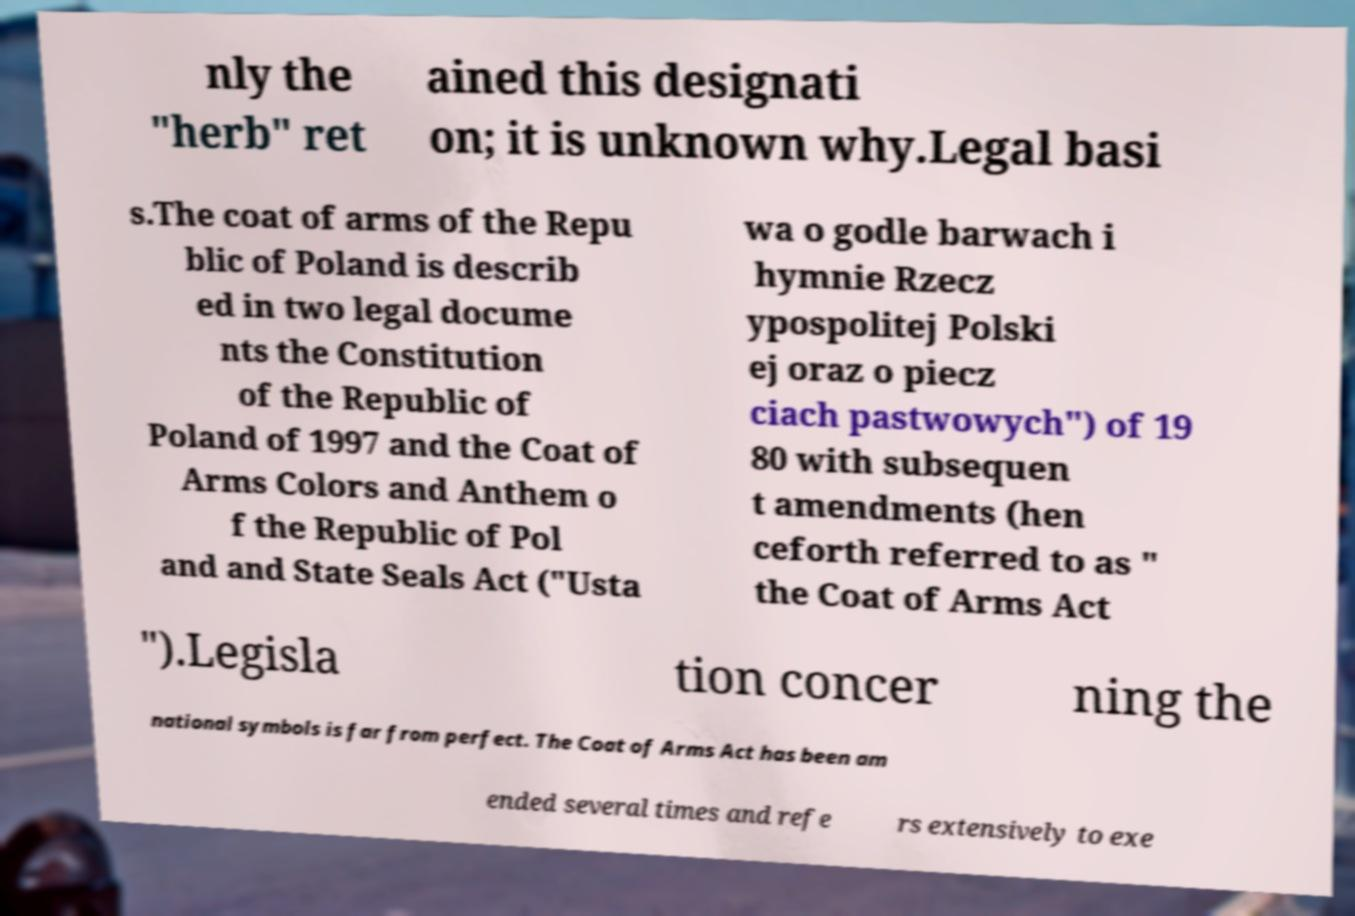Can you accurately transcribe the text from the provided image for me? nly the "herb" ret ained this designati on; it is unknown why.Legal basi s.The coat of arms of the Repu blic of Poland is describ ed in two legal docume nts the Constitution of the Republic of Poland of 1997 and the Coat of Arms Colors and Anthem o f the Republic of Pol and and State Seals Act ("Usta wa o godle barwach i hymnie Rzecz ypospolitej Polski ej oraz o piecz ciach pastwowych") of 19 80 with subsequen t amendments (hen ceforth referred to as " the Coat of Arms Act ").Legisla tion concer ning the national symbols is far from perfect. The Coat of Arms Act has been am ended several times and refe rs extensively to exe 